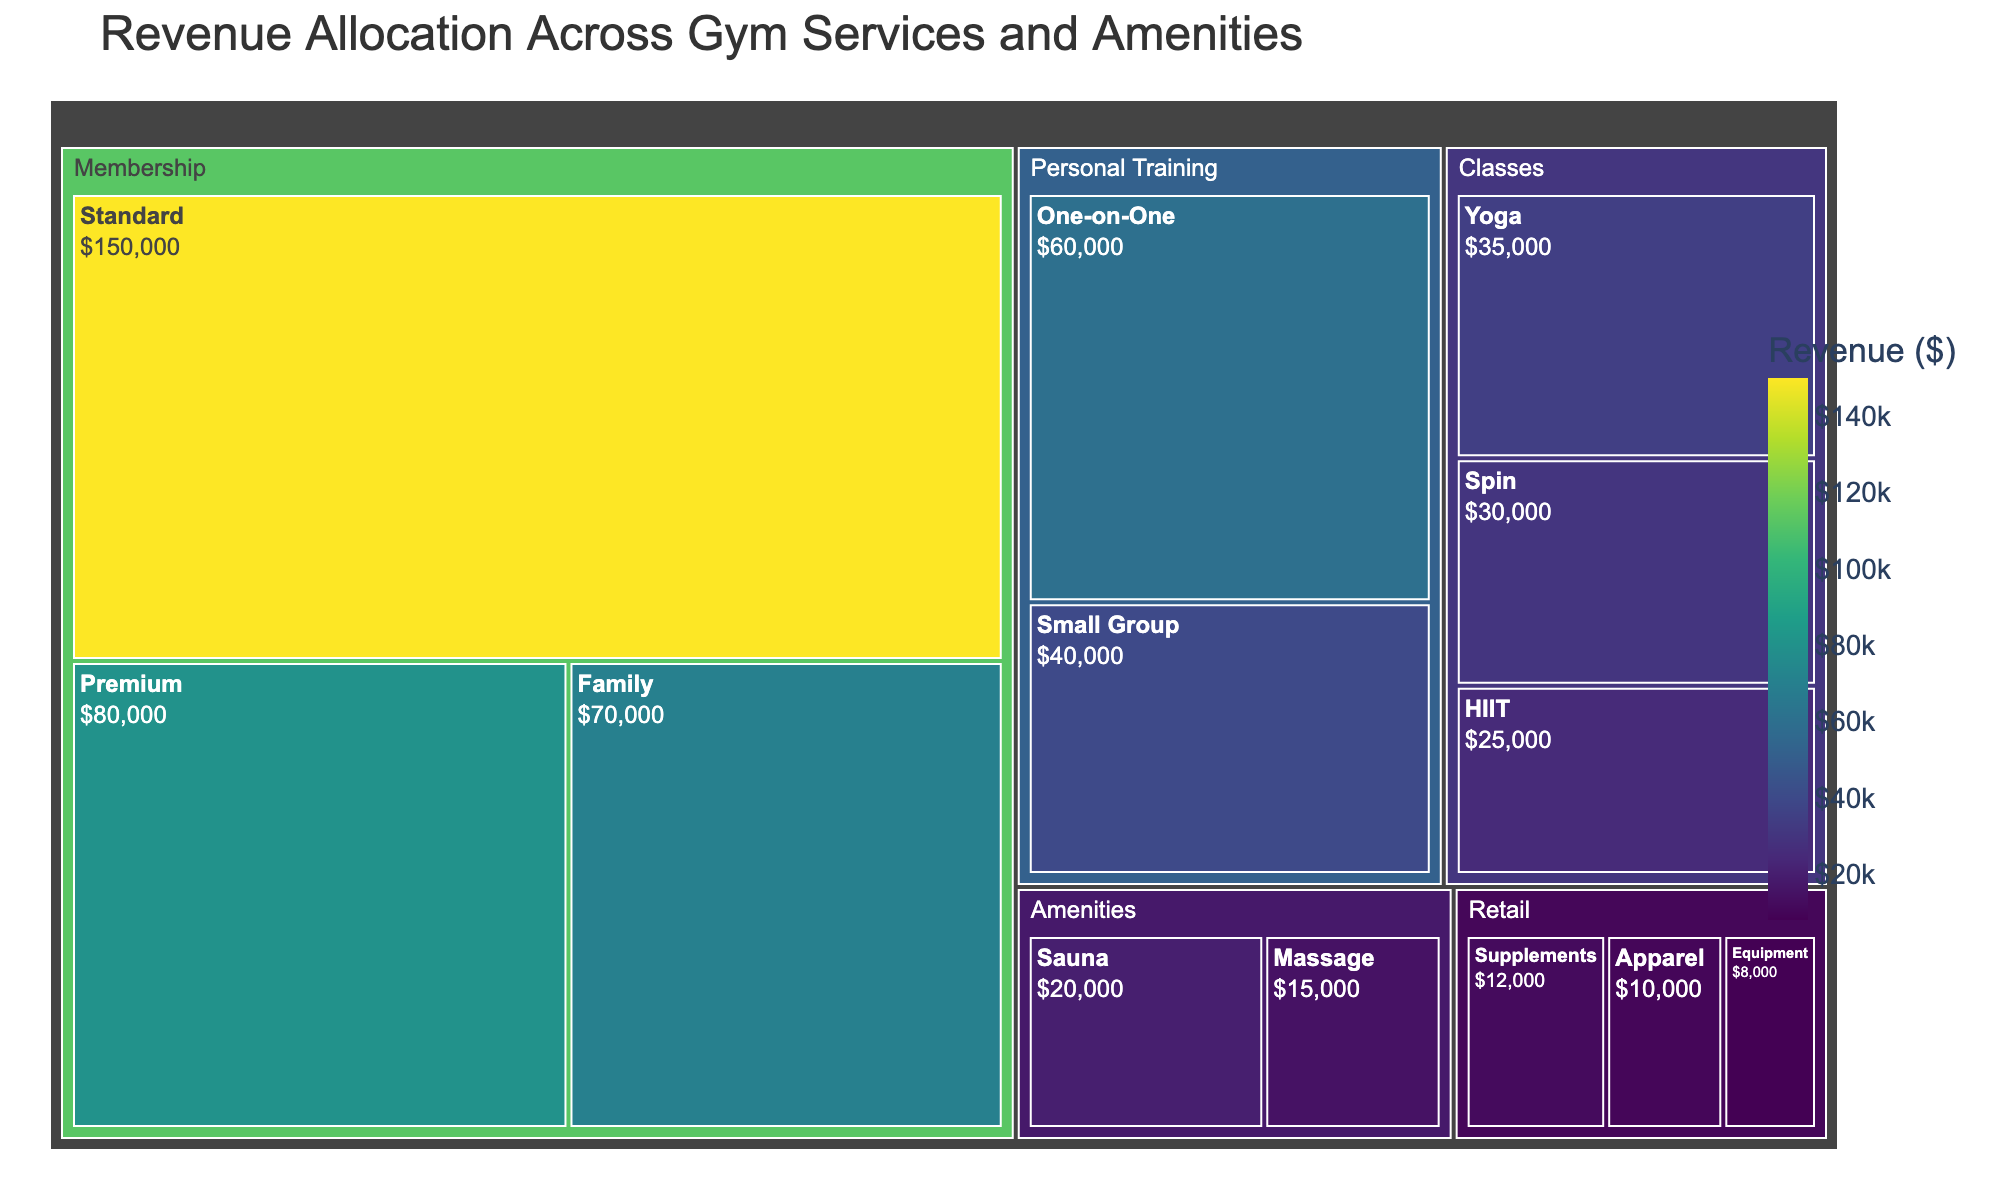What is the title of the treemap? The title of the treemap is displayed prominently at the top. It is meant to provide a clear indication of what the visual representation is about.
Answer: Revenue Allocation Across Gym Services and Amenities Which category generates the highest revenue? To determine this, look at the overall size of each primary category block in the treemap. The one with the largest proportion represents the highest revenue.
Answer: Membership Which subcategory under "Membership" generates the highest revenue? Look within the "Membership" category and identify the subcategory with the largest block.
Answer: Standard What is the total revenue generated by the "Classes" category? Add up the revenues of all subcategories under the "Classes" category: Yoga ($35,000), Spin ($30,000), and HIIT ($25,000).
Answer: $90,000 How much more revenue does "Personal Training" generate compared to "Retail"? First, sum the revenues of all subcategories under "Personal Training" and "Retail". Personal Training: One-on-One ($60,000) + Small Group ($40,000) = $100,000. Retail: Supplements ($12,000) + Apparel ($10,000) + Equipment ($8,000) = $30,000. Then, subtract the total revenue of "Retail" from "Personal Training".
Answer: $70,000 Which subcategory under "Amenities" generates less revenue than "Sauna"? Compare the revenue blocks under "Amenities". Sauna has a revenue of $20,000. Then, check the revenues mentioned for other subcategories under "Amenities".
Answer: Massage How does the revenue for "HIIT" compare to "Yoga"? Look at the "Classes" category to compare the blocks of "HIIT" and "Yoga". Examine the revenue values for each: HIIT ($25,000) and Yoga ($35,000).
Answer: HIIT generates $10,000 less than Yoga What is the combined revenue of "Small Group" Personal Training and "Spin" classes? Add the revenue of Small Group ($40,000) and Spin ($30,000).
Answer: $70,000 Which category has the smallest total revenue? Identify the category with the smallest overall block size on the treemap.
Answer: Retail What is the difference between the revenues of "Standard" Membership and "Premium" Membership? Subtract the revenue of Premium Membership ($80,000) from the revenue of Standard Membership ($150,000).
Answer: $70,000 